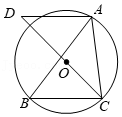In the given geometric figure, if BC were extended to meet a line through A, creating a new intersection point E, what would be the measure of angle AED? As AD is parallel to BC and E is a point on the extended line of BC, angle AED would be equal to angle BAC. Since the original angle BAC is 50°, angle AED would also be 50° because of the Corresponding Angles Theorem where parallel lines create equal alternate angles. 